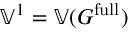Convert formula to latex. <formula><loc_0><loc_0><loc_500><loc_500>\mathbb { V } ^ { 1 } = \mathbb { V } ( G ^ { f u l l } )</formula> 